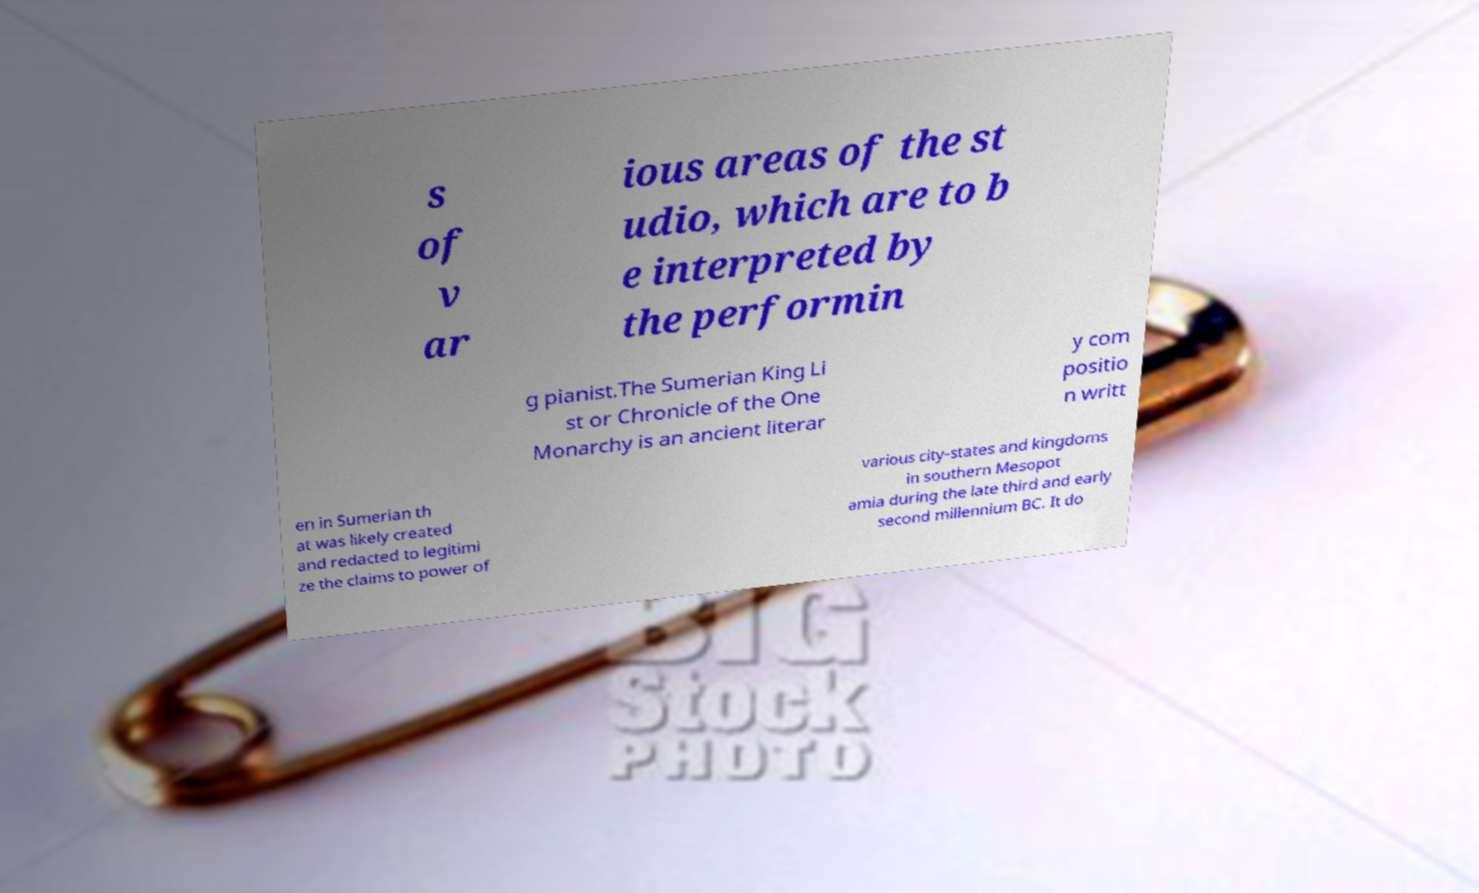Can you accurately transcribe the text from the provided image for me? s of v ar ious areas of the st udio, which are to b e interpreted by the performin g pianist.The Sumerian King Li st or Chronicle of the One Monarchy is an ancient literar y com positio n writt en in Sumerian th at was likely created and redacted to legitimi ze the claims to power of various city-states and kingdoms in southern Mesopot amia during the late third and early second millennium BC. It do 